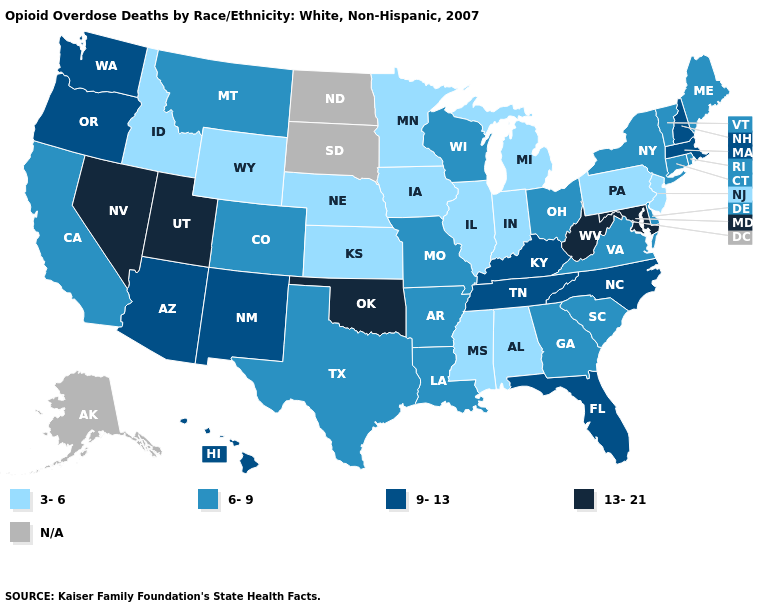What is the highest value in the USA?
Short answer required. 13-21. What is the value of Maryland?
Write a very short answer. 13-21. What is the value of Florida?
Write a very short answer. 9-13. Does the map have missing data?
Answer briefly. Yes. What is the highest value in states that border Oklahoma?
Quick response, please. 9-13. Name the states that have a value in the range 6-9?
Short answer required. Arkansas, California, Colorado, Connecticut, Delaware, Georgia, Louisiana, Maine, Missouri, Montana, New York, Ohio, Rhode Island, South Carolina, Texas, Vermont, Virginia, Wisconsin. What is the lowest value in the USA?
Concise answer only. 3-6. Name the states that have a value in the range 9-13?
Quick response, please. Arizona, Florida, Hawaii, Kentucky, Massachusetts, New Hampshire, New Mexico, North Carolina, Oregon, Tennessee, Washington. What is the highest value in the USA?
Be succinct. 13-21. What is the value of Wyoming?
Write a very short answer. 3-6. Does Nevada have the highest value in the USA?
Be succinct. Yes. Does New Jersey have the lowest value in the Northeast?
Give a very brief answer. Yes. 